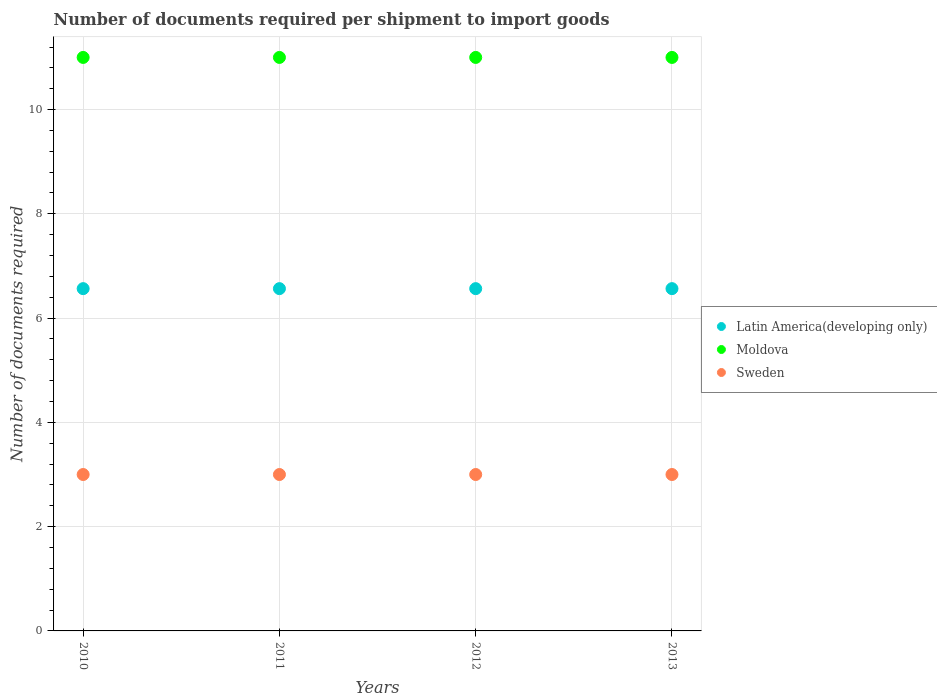How many different coloured dotlines are there?
Your response must be concise. 3. Is the number of dotlines equal to the number of legend labels?
Your answer should be compact. Yes. What is the number of documents required per shipment to import goods in Latin America(developing only) in 2012?
Your answer should be very brief. 6.57. Across all years, what is the maximum number of documents required per shipment to import goods in Sweden?
Your response must be concise. 3. Across all years, what is the minimum number of documents required per shipment to import goods in Latin America(developing only)?
Provide a succinct answer. 6.57. In which year was the number of documents required per shipment to import goods in Latin America(developing only) minimum?
Offer a very short reply. 2010. What is the total number of documents required per shipment to import goods in Sweden in the graph?
Give a very brief answer. 12. What is the difference between the number of documents required per shipment to import goods in Sweden in 2011 and that in 2013?
Your answer should be very brief. 0. What is the difference between the number of documents required per shipment to import goods in Latin America(developing only) in 2013 and the number of documents required per shipment to import goods in Moldova in 2010?
Make the answer very short. -4.43. In the year 2011, what is the difference between the number of documents required per shipment to import goods in Sweden and number of documents required per shipment to import goods in Latin America(developing only)?
Make the answer very short. -3.57. In how many years, is the number of documents required per shipment to import goods in Latin America(developing only) greater than 2?
Your answer should be compact. 4. Is the number of documents required per shipment to import goods in Moldova in 2011 less than that in 2013?
Make the answer very short. No. Is the difference between the number of documents required per shipment to import goods in Sweden in 2011 and 2012 greater than the difference between the number of documents required per shipment to import goods in Latin America(developing only) in 2011 and 2012?
Give a very brief answer. No. Is the sum of the number of documents required per shipment to import goods in Moldova in 2012 and 2013 greater than the maximum number of documents required per shipment to import goods in Sweden across all years?
Offer a very short reply. Yes. Is it the case that in every year, the sum of the number of documents required per shipment to import goods in Moldova and number of documents required per shipment to import goods in Sweden  is greater than the number of documents required per shipment to import goods in Latin America(developing only)?
Keep it short and to the point. Yes. Is the number of documents required per shipment to import goods in Moldova strictly greater than the number of documents required per shipment to import goods in Latin America(developing only) over the years?
Ensure brevity in your answer.  Yes. Is the number of documents required per shipment to import goods in Sweden strictly less than the number of documents required per shipment to import goods in Moldova over the years?
Offer a terse response. Yes. How many dotlines are there?
Make the answer very short. 3. Are the values on the major ticks of Y-axis written in scientific E-notation?
Provide a succinct answer. No. Does the graph contain any zero values?
Your response must be concise. No. Does the graph contain grids?
Provide a short and direct response. Yes. Where does the legend appear in the graph?
Ensure brevity in your answer.  Center right. What is the title of the graph?
Ensure brevity in your answer.  Number of documents required per shipment to import goods. What is the label or title of the X-axis?
Provide a short and direct response. Years. What is the label or title of the Y-axis?
Your answer should be very brief. Number of documents required. What is the Number of documents required of Latin America(developing only) in 2010?
Ensure brevity in your answer.  6.57. What is the Number of documents required in Latin America(developing only) in 2011?
Your answer should be compact. 6.57. What is the Number of documents required of Latin America(developing only) in 2012?
Your answer should be compact. 6.57. What is the Number of documents required of Sweden in 2012?
Provide a short and direct response. 3. What is the Number of documents required in Latin America(developing only) in 2013?
Give a very brief answer. 6.57. Across all years, what is the maximum Number of documents required in Latin America(developing only)?
Your answer should be compact. 6.57. Across all years, what is the maximum Number of documents required in Sweden?
Your response must be concise. 3. Across all years, what is the minimum Number of documents required of Latin America(developing only)?
Provide a short and direct response. 6.57. Across all years, what is the minimum Number of documents required of Sweden?
Provide a short and direct response. 3. What is the total Number of documents required in Latin America(developing only) in the graph?
Offer a terse response. 26.26. What is the total Number of documents required of Sweden in the graph?
Ensure brevity in your answer.  12. What is the difference between the Number of documents required in Moldova in 2010 and that in 2011?
Your answer should be very brief. 0. What is the difference between the Number of documents required in Sweden in 2010 and that in 2011?
Your answer should be compact. 0. What is the difference between the Number of documents required in Latin America(developing only) in 2010 and that in 2012?
Offer a terse response. 0. What is the difference between the Number of documents required of Moldova in 2010 and that in 2012?
Your answer should be compact. 0. What is the difference between the Number of documents required in Sweden in 2010 and that in 2013?
Make the answer very short. 0. What is the difference between the Number of documents required of Moldova in 2011 and that in 2012?
Provide a succinct answer. 0. What is the difference between the Number of documents required in Sweden in 2011 and that in 2012?
Keep it short and to the point. 0. What is the difference between the Number of documents required of Moldova in 2011 and that in 2013?
Your answer should be compact. 0. What is the difference between the Number of documents required of Latin America(developing only) in 2010 and the Number of documents required of Moldova in 2011?
Ensure brevity in your answer.  -4.43. What is the difference between the Number of documents required of Latin America(developing only) in 2010 and the Number of documents required of Sweden in 2011?
Provide a succinct answer. 3.57. What is the difference between the Number of documents required in Moldova in 2010 and the Number of documents required in Sweden in 2011?
Offer a terse response. 8. What is the difference between the Number of documents required of Latin America(developing only) in 2010 and the Number of documents required of Moldova in 2012?
Offer a very short reply. -4.43. What is the difference between the Number of documents required of Latin America(developing only) in 2010 and the Number of documents required of Sweden in 2012?
Your answer should be very brief. 3.57. What is the difference between the Number of documents required of Moldova in 2010 and the Number of documents required of Sweden in 2012?
Offer a very short reply. 8. What is the difference between the Number of documents required in Latin America(developing only) in 2010 and the Number of documents required in Moldova in 2013?
Offer a very short reply. -4.43. What is the difference between the Number of documents required in Latin America(developing only) in 2010 and the Number of documents required in Sweden in 2013?
Make the answer very short. 3.57. What is the difference between the Number of documents required in Latin America(developing only) in 2011 and the Number of documents required in Moldova in 2012?
Offer a very short reply. -4.43. What is the difference between the Number of documents required in Latin America(developing only) in 2011 and the Number of documents required in Sweden in 2012?
Offer a terse response. 3.57. What is the difference between the Number of documents required of Moldova in 2011 and the Number of documents required of Sweden in 2012?
Your answer should be compact. 8. What is the difference between the Number of documents required of Latin America(developing only) in 2011 and the Number of documents required of Moldova in 2013?
Offer a terse response. -4.43. What is the difference between the Number of documents required of Latin America(developing only) in 2011 and the Number of documents required of Sweden in 2013?
Your response must be concise. 3.57. What is the difference between the Number of documents required in Moldova in 2011 and the Number of documents required in Sweden in 2013?
Provide a succinct answer. 8. What is the difference between the Number of documents required of Latin America(developing only) in 2012 and the Number of documents required of Moldova in 2013?
Keep it short and to the point. -4.43. What is the difference between the Number of documents required of Latin America(developing only) in 2012 and the Number of documents required of Sweden in 2013?
Provide a succinct answer. 3.57. What is the difference between the Number of documents required in Moldova in 2012 and the Number of documents required in Sweden in 2013?
Offer a very short reply. 8. What is the average Number of documents required in Latin America(developing only) per year?
Make the answer very short. 6.57. In the year 2010, what is the difference between the Number of documents required in Latin America(developing only) and Number of documents required in Moldova?
Keep it short and to the point. -4.43. In the year 2010, what is the difference between the Number of documents required in Latin America(developing only) and Number of documents required in Sweden?
Offer a terse response. 3.57. In the year 2011, what is the difference between the Number of documents required of Latin America(developing only) and Number of documents required of Moldova?
Your answer should be very brief. -4.43. In the year 2011, what is the difference between the Number of documents required of Latin America(developing only) and Number of documents required of Sweden?
Your answer should be compact. 3.57. In the year 2011, what is the difference between the Number of documents required in Moldova and Number of documents required in Sweden?
Offer a very short reply. 8. In the year 2012, what is the difference between the Number of documents required of Latin America(developing only) and Number of documents required of Moldova?
Provide a short and direct response. -4.43. In the year 2012, what is the difference between the Number of documents required in Latin America(developing only) and Number of documents required in Sweden?
Offer a very short reply. 3.57. In the year 2013, what is the difference between the Number of documents required of Latin America(developing only) and Number of documents required of Moldova?
Give a very brief answer. -4.43. In the year 2013, what is the difference between the Number of documents required in Latin America(developing only) and Number of documents required in Sweden?
Make the answer very short. 3.57. In the year 2013, what is the difference between the Number of documents required in Moldova and Number of documents required in Sweden?
Offer a terse response. 8. What is the ratio of the Number of documents required in Latin America(developing only) in 2010 to that in 2011?
Your answer should be very brief. 1. What is the ratio of the Number of documents required of Sweden in 2010 to that in 2011?
Ensure brevity in your answer.  1. What is the ratio of the Number of documents required in Latin America(developing only) in 2010 to that in 2012?
Provide a succinct answer. 1. What is the ratio of the Number of documents required of Moldova in 2010 to that in 2013?
Your answer should be very brief. 1. What is the ratio of the Number of documents required in Latin America(developing only) in 2011 to that in 2012?
Ensure brevity in your answer.  1. What is the ratio of the Number of documents required of Moldova in 2011 to that in 2012?
Make the answer very short. 1. What is the ratio of the Number of documents required of Latin America(developing only) in 2012 to that in 2013?
Ensure brevity in your answer.  1. What is the ratio of the Number of documents required of Moldova in 2012 to that in 2013?
Provide a succinct answer. 1. What is the ratio of the Number of documents required of Sweden in 2012 to that in 2013?
Provide a succinct answer. 1. What is the difference between the highest and the second highest Number of documents required of Sweden?
Provide a short and direct response. 0. What is the difference between the highest and the lowest Number of documents required of Latin America(developing only)?
Make the answer very short. 0. 